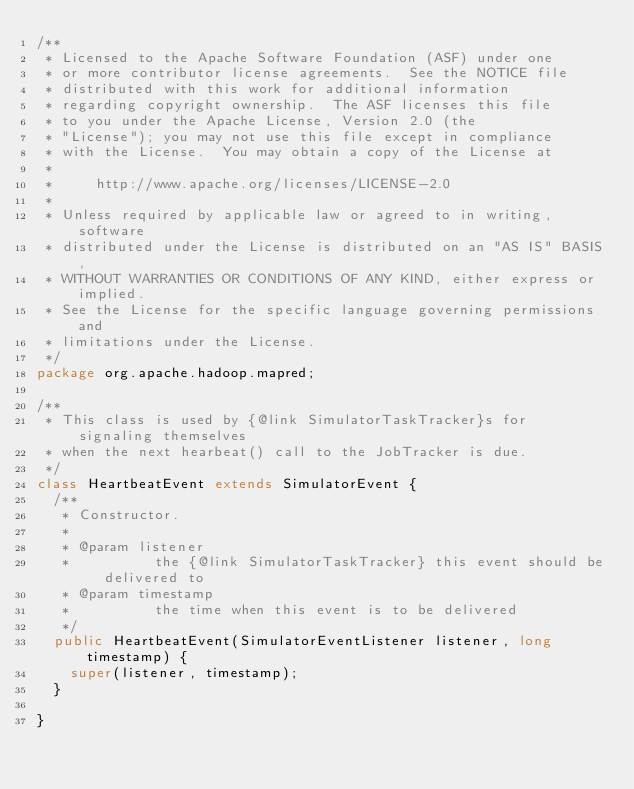<code> <loc_0><loc_0><loc_500><loc_500><_Java_>/**
 * Licensed to the Apache Software Foundation (ASF) under one
 * or more contributor license agreements.  See the NOTICE file
 * distributed with this work for additional information
 * regarding copyright ownership.  The ASF licenses this file
 * to you under the Apache License, Version 2.0 (the
 * "License"); you may not use this file except in compliance
 * with the License.  You may obtain a copy of the License at
 *
 *     http://www.apache.org/licenses/LICENSE-2.0
 *
 * Unless required by applicable law or agreed to in writing, software
 * distributed under the License is distributed on an "AS IS" BASIS,
 * WITHOUT WARRANTIES OR CONDITIONS OF ANY KIND, either express or implied.
 * See the License for the specific language governing permissions and
 * limitations under the License.
 */
package org.apache.hadoop.mapred;

/**
 * This class is used by {@link SimulatorTaskTracker}s for signaling themselves
 * when the next hearbeat() call to the JobTracker is due.
 */
class HeartbeatEvent extends SimulatorEvent {
  /**
   * Constructor.
   * 
   * @param listener
   *          the {@link SimulatorTaskTracker} this event should be delivered to
   * @param timestamp
   *          the time when this event is to be delivered
   */
  public HeartbeatEvent(SimulatorEventListener listener, long timestamp) {
    super(listener, timestamp);
  }

}
</code> 